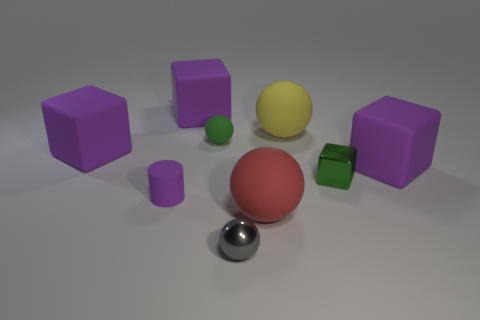How many blocks are small purple objects or tiny green things?
Keep it short and to the point. 1. There is a rubber block that is behind the green object that is left of the green thing that is to the right of the green matte ball; how big is it?
Give a very brief answer. Large. Are there any matte balls on the right side of the tiny gray metal sphere?
Make the answer very short. Yes. There is a object that is the same color as the small block; what is its shape?
Your answer should be very brief. Sphere. How many objects are purple rubber cubes that are behind the green rubber ball or yellow rubber spheres?
Provide a succinct answer. 2. The red sphere that is made of the same material as the tiny purple object is what size?
Offer a terse response. Large. There is a green matte ball; is its size the same as the thing in front of the large red ball?
Give a very brief answer. Yes. What color is the thing that is behind the green block and on the right side of the large yellow matte sphere?
Your response must be concise. Purple. How many things are rubber balls on the right side of the small green matte ball or big balls behind the small matte sphere?
Your answer should be very brief. 2. There is a object right of the small object right of the metallic object to the left of the small block; what color is it?
Ensure brevity in your answer.  Purple. 